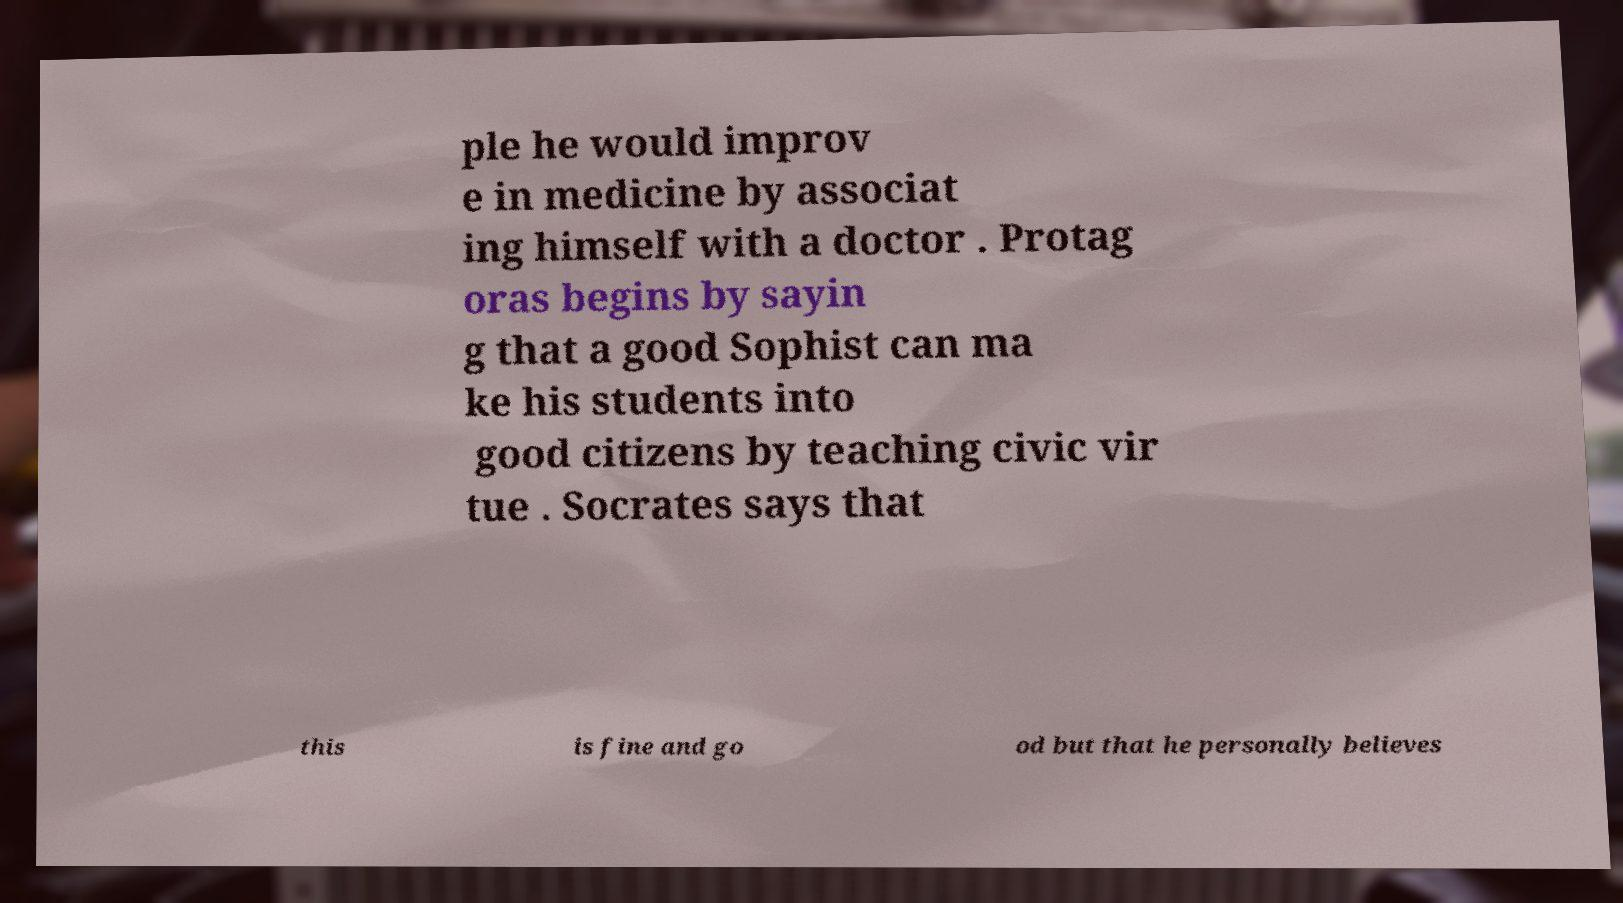Can you accurately transcribe the text from the provided image for me? ple he would improv e in medicine by associat ing himself with a doctor . Protag oras begins by sayin g that a good Sophist can ma ke his students into good citizens by teaching civic vir tue . Socrates says that this is fine and go od but that he personally believes 